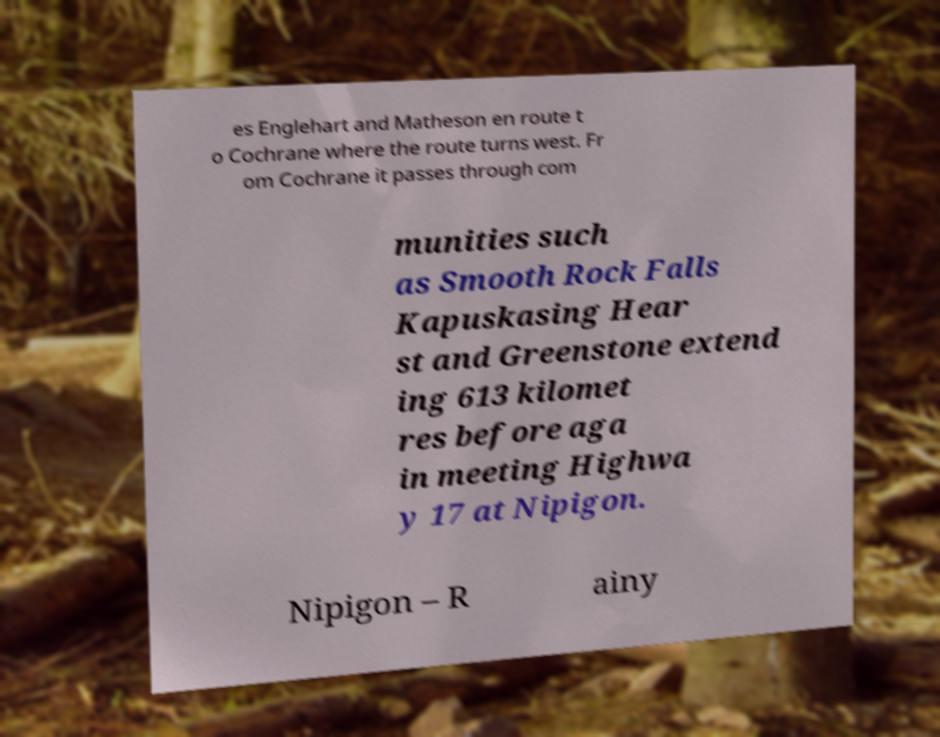Please read and relay the text visible in this image. What does it say? es Englehart and Matheson en route t o Cochrane where the route turns west. Fr om Cochrane it passes through com munities such as Smooth Rock Falls Kapuskasing Hear st and Greenstone extend ing 613 kilomet res before aga in meeting Highwa y 17 at Nipigon. Nipigon – R ainy 